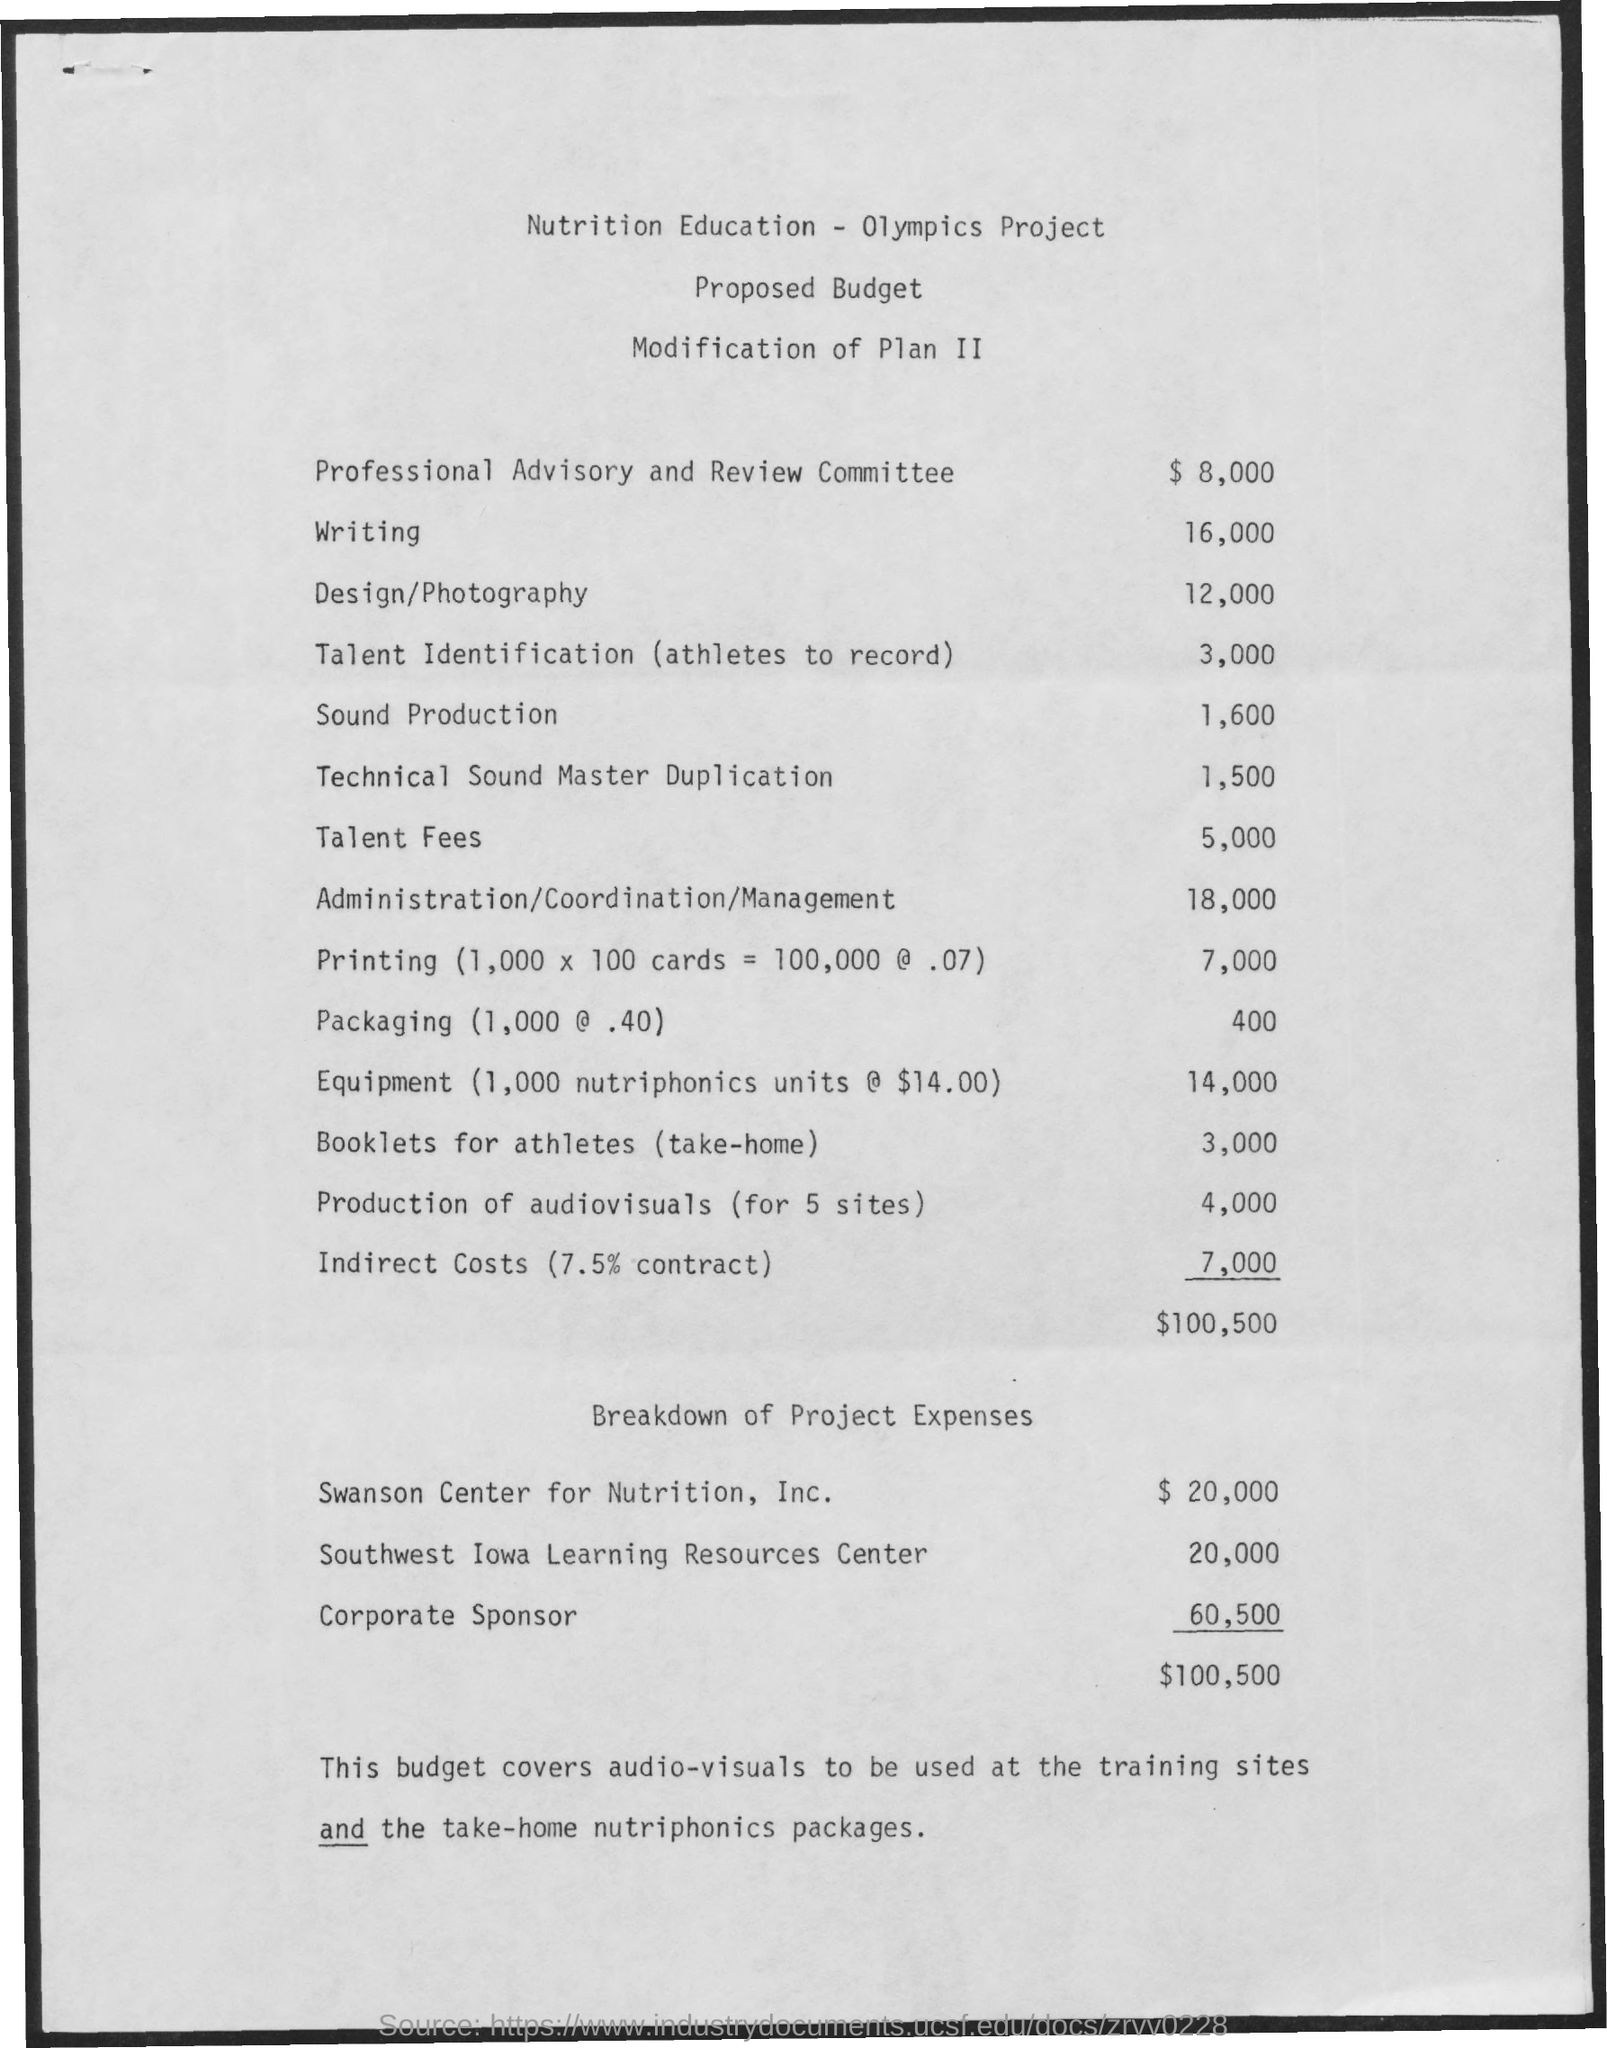What is the budget mentioned for professional advisory and review committee ?
Your answer should be compact. $ 8,000. What is the budget mentioned for writing ?
Your response must be concise. 16,000. What is the budget mentioned for design/ photography ?
Your answer should be compact. 12,000. What is the budget mentioned for sound production ?
Your response must be concise. 1,600. What is the amount mentioned for indirect costs ?
Your answer should be very brief. 7,000. What is the amount of expenses given for swanson center for nutrition, inc. ?
Your answer should be compact. $ 20,000. What is the amount mentioned for southwest iowa learning resources center ?
Your response must be concise. 20,000. What is the amount of expenses mentioned for corporate sponsor ?
Ensure brevity in your answer.  60,500. 